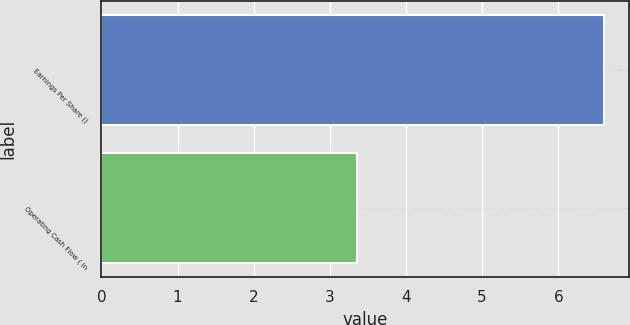Convert chart. <chart><loc_0><loc_0><loc_500><loc_500><bar_chart><fcel>Earnings Per Share ()<fcel>Operating Cash Flow ( in<nl><fcel>6.6<fcel>3.35<nl></chart> 